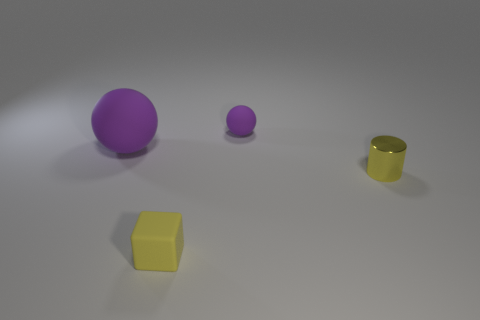What is the texture of the yellow cube? The yellow cube appears to have a matte texture, which diffuses the light and gives it a soft, non-reflective surface. 